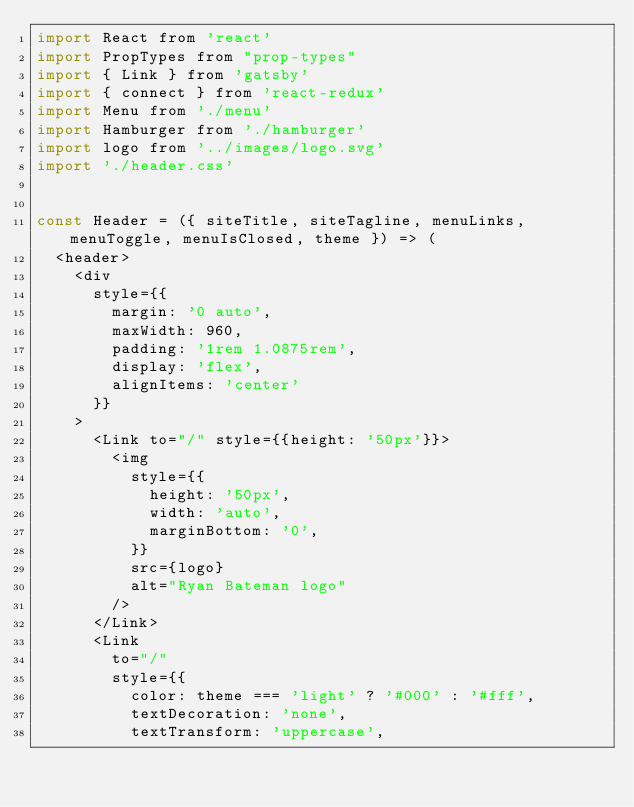<code> <loc_0><loc_0><loc_500><loc_500><_JavaScript_>import React from 'react'
import PropTypes from "prop-types"
import { Link } from 'gatsby'
import { connect } from 'react-redux'
import Menu from './menu'
import Hamburger from './hamburger'
import logo from '../images/logo.svg'
import './header.css'


const Header = ({ siteTitle, siteTagline, menuLinks, menuToggle, menuIsClosed, theme }) => (
  <header>
    <div
      style={{
        margin: '0 auto',
        maxWidth: 960,
        padding: '1rem 1.0875rem',
        display: 'flex',
        alignItems: 'center'
      }}
    >
      <Link to="/" style={{height: '50px'}}>
        <img
          style={{
            height: '50px',
            width: 'auto',
            marginBottom: '0',
          }}
          src={logo}
          alt="Ryan Bateman logo"
        />
      </Link>
      <Link
        to="/"
        style={{
          color: theme === 'light' ? '#000' : '#fff',
          textDecoration: 'none',
          textTransform: 'uppercase',</code> 